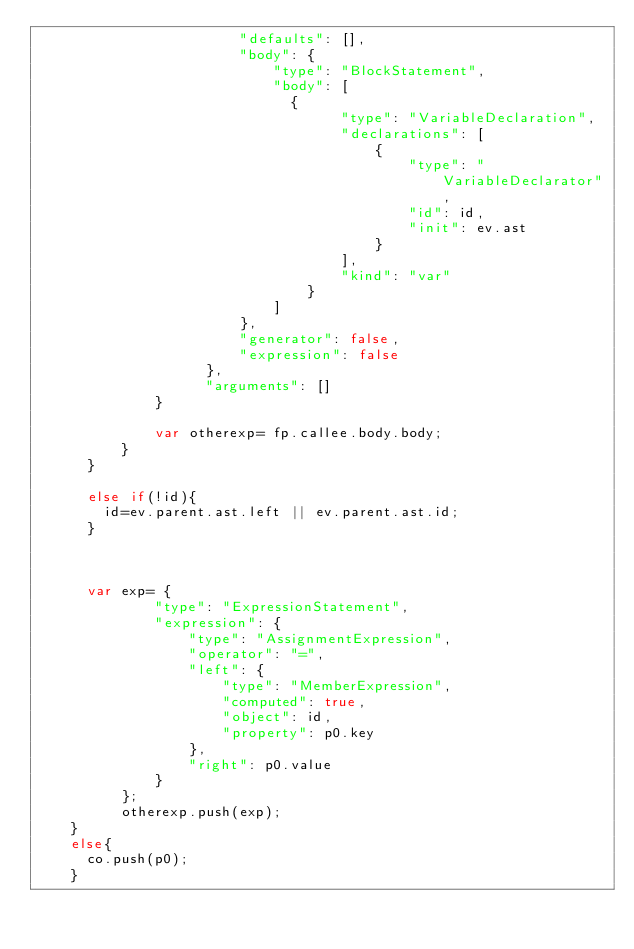<code> <loc_0><loc_0><loc_500><loc_500><_JavaScript_>		                    "defaults": [],
		                    "body": {
		                        "type": "BlockStatement",
		                        "body": [
			                        {
	                                	"type": "VariableDeclaration",
		                                "declarations": [
		                                    {
		                                        "type": "VariableDeclarator",
		                                        "id": id,
		                                        "init": ev.ast
		                                    }
		                                ],
		                                "kind": "var"
		                            }
		                        ]
		                    },
		                    "generator": false,
		                    "expression": false
		                },
		                "arguments": []
			        }

			        var otherexp= fp.callee.body.body;
			    }
			}

			else if(!id){
				id=ev.parent.ast.left || ev.parent.ast.id;
			}


			
			var exp= {
	            "type": "ExpressionStatement",
	            "expression": {
	                "type": "AssignmentExpression",
	                "operator": "=",
	                "left": {
	                    "type": "MemberExpression",
	                    "computed": true,
	                    "object": id,
	                    "property": p0.key
	                },
	                "right": p0.value
	            }
	        };
	        otherexp.push(exp);
		}	
		else{
			co.push(p0);
		}</code> 